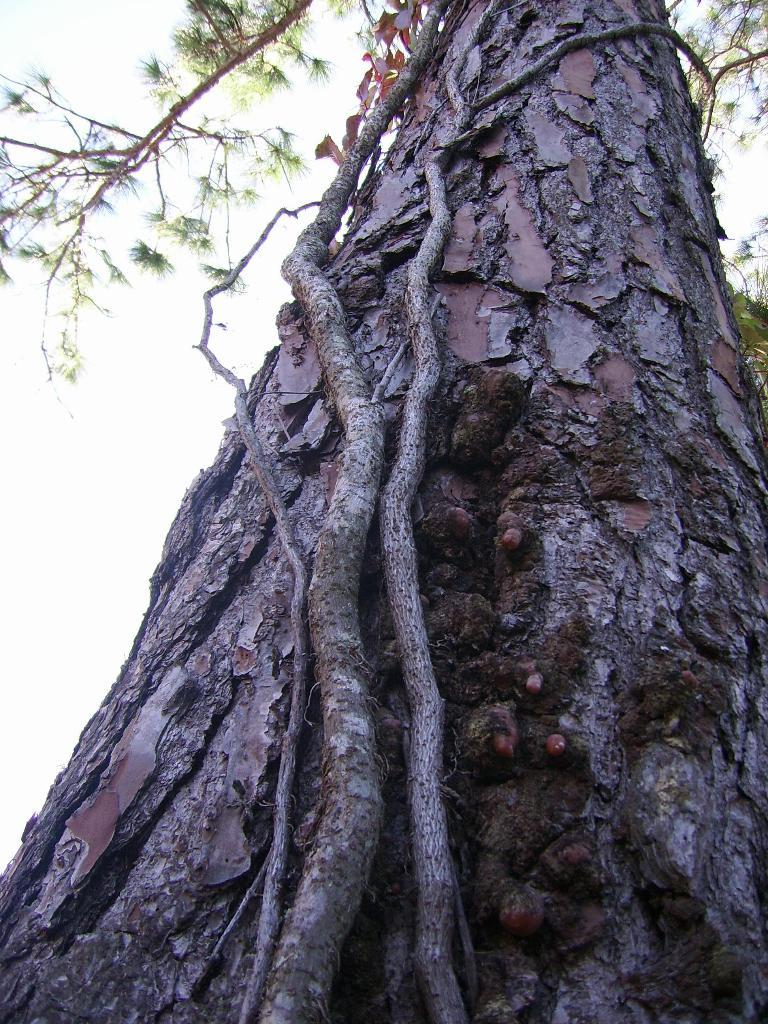What is the main subject of the image? The main subject of the image is a tree. Can you describe the tree's features? The tree has roots and branches. What is the color of the background in the image? The background of the image is white. How many pizzas are stacked on the tree in the image? There are no pizzas present in the image; it features a tree with roots and branches. What type of badge can be seen hanging from the tree in the image? There is no badge present in the image; it features a tree with roots and branches against a white background. 